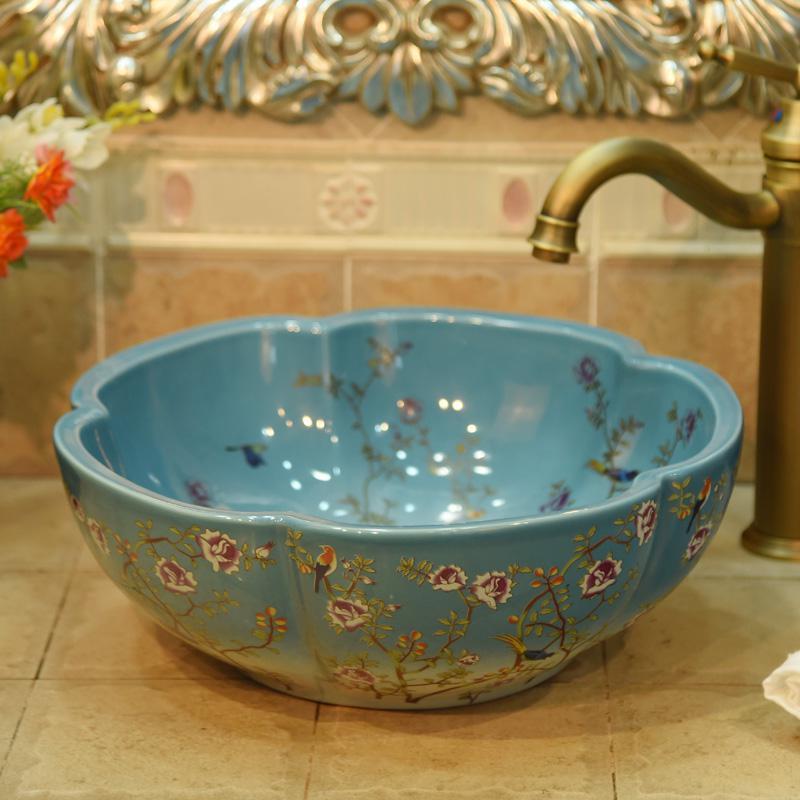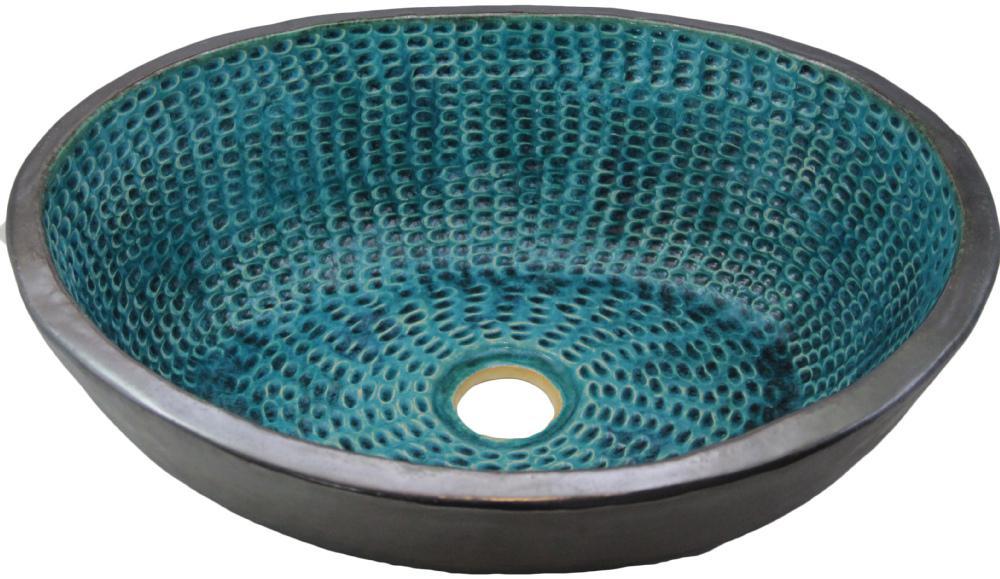The first image is the image on the left, the second image is the image on the right. Evaluate the accuracy of this statement regarding the images: "A gold-colored spout extends over a vessel sink with a decorated exterior set atop a tile counter in the left image, and the right image shows a sink with a hole inside.". Is it true? Answer yes or no. Yes. The first image is the image on the left, the second image is the image on the right. For the images shown, is this caption "There is a sink bowl underneath a faucet." true? Answer yes or no. Yes. 